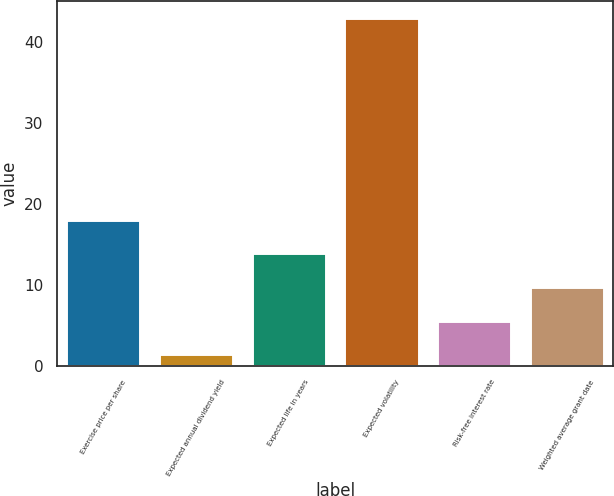<chart> <loc_0><loc_0><loc_500><loc_500><bar_chart><fcel>Exercise price per share<fcel>Expected annual dividend yield<fcel>Expected life in years<fcel>Expected volatility<fcel>Risk-free interest rate<fcel>Weighted average grant date<nl><fcel>18.04<fcel>1.4<fcel>13.88<fcel>43<fcel>5.56<fcel>9.72<nl></chart> 